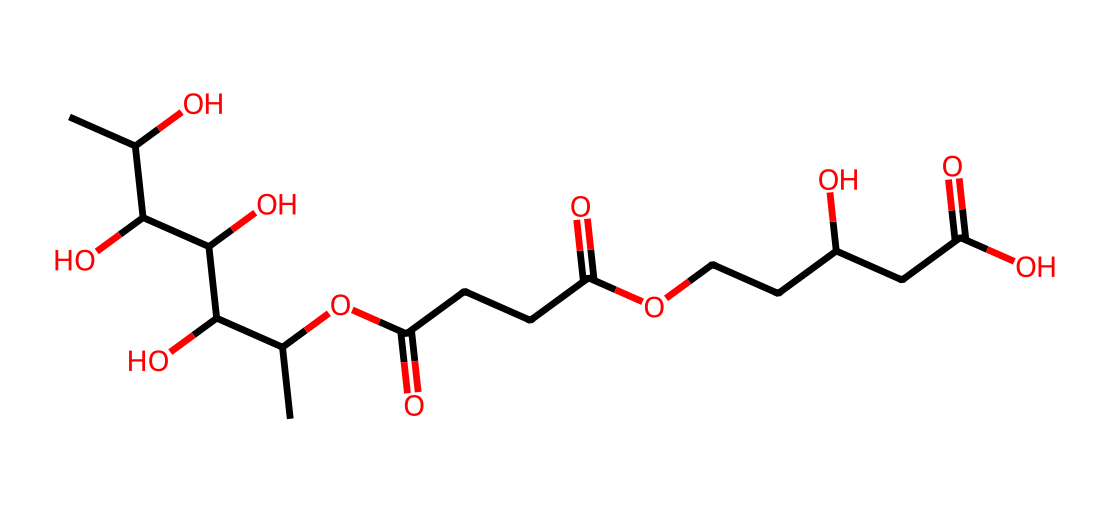What is the total number of carbon atoms in this rhamnolipid? By analyzing the SMILES representation, we can count the carbon atoms. In the given structure, we start identifying 'C' (carbon) symbols, which appear throughout the SMILES string. After counting, we find there are 16 carbon atoms present.
Answer: 16 How many functional groups are present in this chemical structure? We look for identifiable functional groups such as hydroxyls (-OH), carboxylic acids (-COOH), and esters (-COOR). By breaking down the molecular structure, we discover there are multiple hydroxyl groups (–OH) and two carboxylic acid groups (–COOH), leading to a total of 5 distinct functional groups within the structure.
Answer: 5 What is the primary type of surfactant this chemical represents? Rhamnolipids are categorized as biosurfactants, which naturally occur in microbial environments, specifically produced by certain bacteria. The structure indicated by the SMILES confirms it’s a biosurfactant due to its natural origin and amphiphilic properties.
Answer: biosurfactant What type of interaction is primarily responsible for the surfactant properties of rhamnolipids? The surfactant properties stem from the amphiphilic nature of rhamnolipids, which possess both hydrophilic (water-attracting) and hydrophobic (water-repelling) regions in their structure. This duality allows them to reduce surface tension effectively.
Answer: amphiphilic How many oxygen atoms are in the chemical structure of this rhamnolipid? To determine the number of oxygen atoms, we scan the SMILES for the 'O' symbol, which denotes the presence of oxygen. Counting them reveals there are 6 oxygen atoms present in this specific rhamnolipid structure.
Answer: 6 